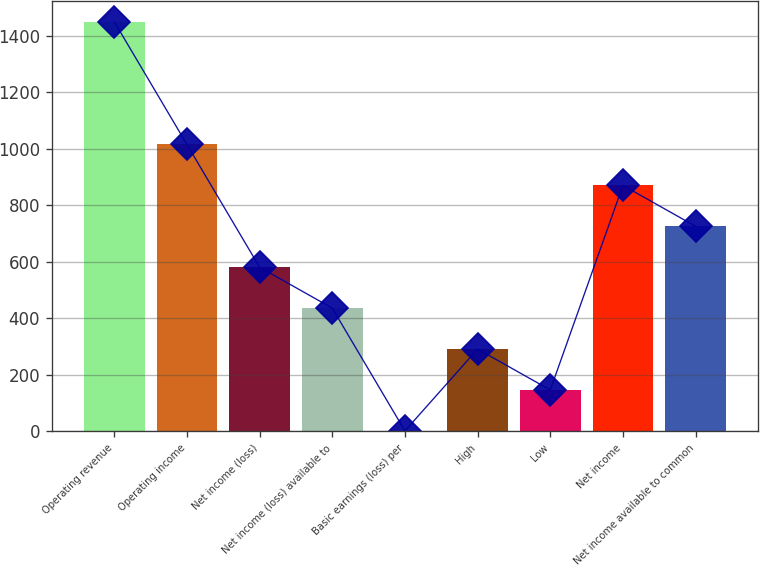Convert chart. <chart><loc_0><loc_0><loc_500><loc_500><bar_chart><fcel>Operating revenue<fcel>Operating income<fcel>Net income (loss)<fcel>Net income (loss) available to<fcel>Basic earnings (loss) per<fcel>High<fcel>Low<fcel>Net income<fcel>Net income available to common<nl><fcel>1449<fcel>1014.42<fcel>579.81<fcel>434.94<fcel>0.33<fcel>290.07<fcel>145.2<fcel>869.55<fcel>724.68<nl></chart> 